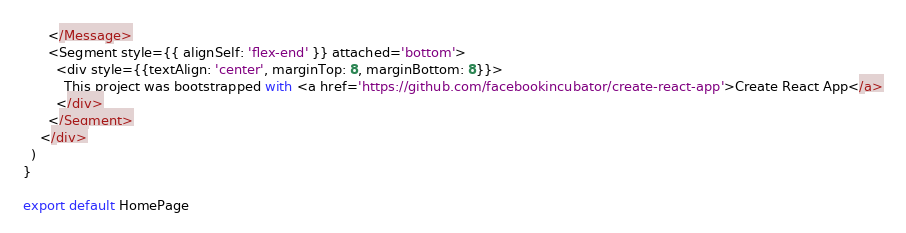Convert code to text. <code><loc_0><loc_0><loc_500><loc_500><_JavaScript_>      </Message>
      <Segment style={{ alignSelf: 'flex-end' }} attached='bottom'>
        <div style={{textAlign: 'center', marginTop: 8, marginBottom: 8}}>
          This project was bootstrapped with <a href='https://github.com/facebookincubator/create-react-app'>Create React App</a>
        </div>
      </Segment>
    </div>
  )
}

export default HomePage
</code> 